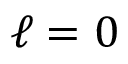Convert formula to latex. <formula><loc_0><loc_0><loc_500><loc_500>\ell = 0</formula> 